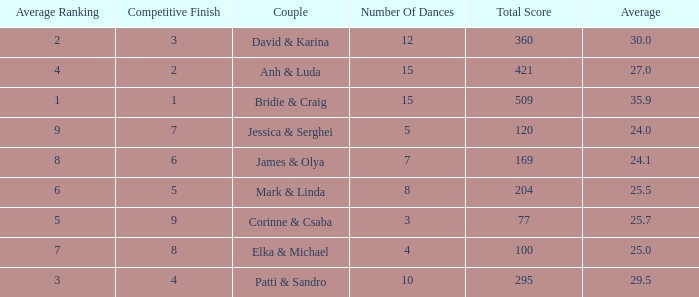What is the total score when 7 is the average ranking? 100.0. 